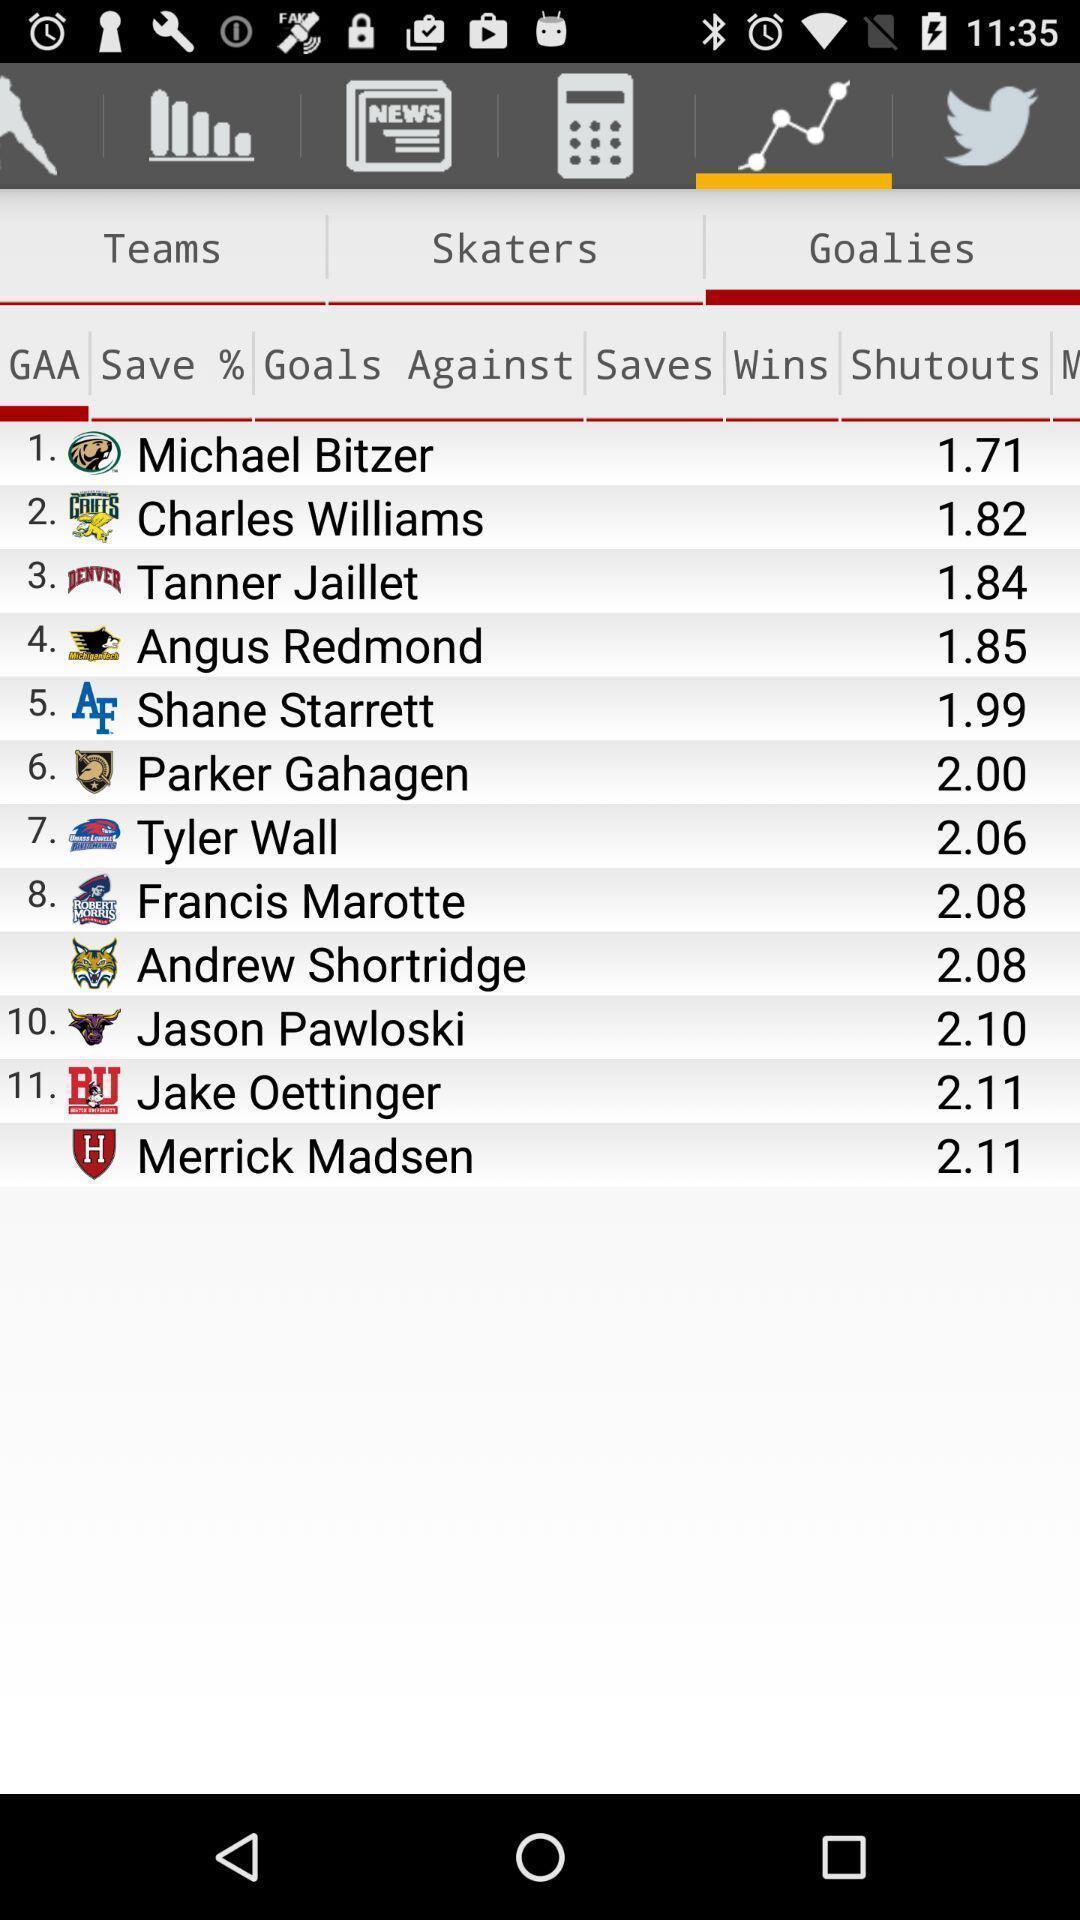Summarize the main components in this picture. Screen showing the list of players. 